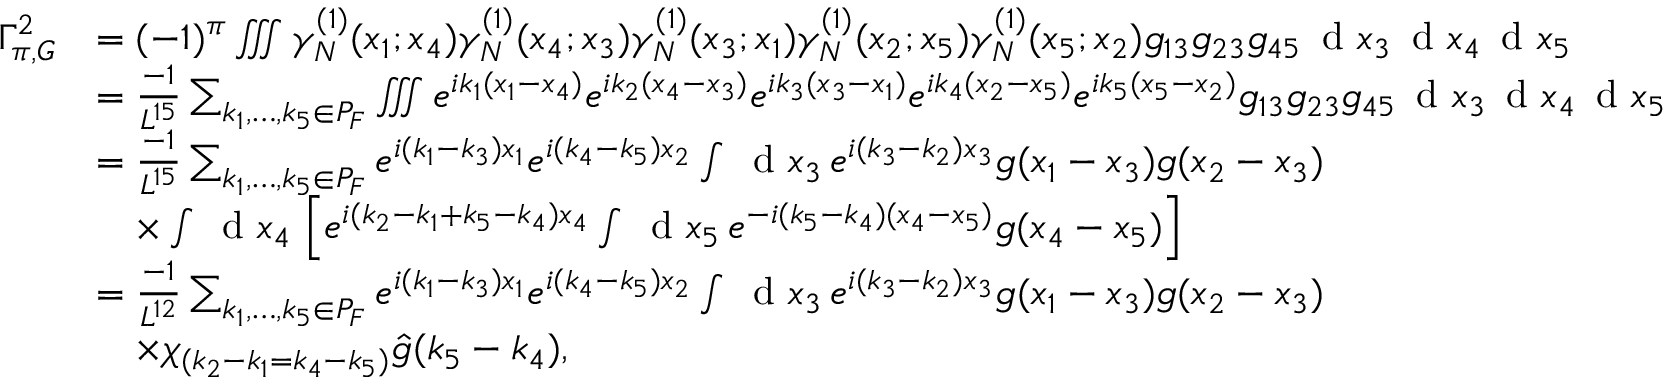Convert formula to latex. <formula><loc_0><loc_0><loc_500><loc_500>\begin{array} { r l } { \Gamma _ { \pi , G } ^ { 2 } } & { = ( - 1 ) ^ { \pi } \iiint \gamma _ { N } ^ { ( 1 ) } ( x _ { 1 } ; x _ { 4 } ) \gamma _ { N } ^ { ( 1 ) } ( x _ { 4 } ; x _ { 3 } ) \gamma _ { N } ^ { ( 1 ) } ( x _ { 3 } ; x _ { 1 } ) \gamma _ { N } ^ { ( 1 ) } ( x _ { 2 } ; x _ { 5 } ) \gamma _ { N } ^ { ( 1 ) } ( x _ { 5 } ; x _ { 2 } ) g _ { 1 3 } g _ { 2 3 } g _ { 4 5 } \, d x _ { 3 } \, d x _ { 4 } \, d x _ { 5 } } \\ & { = \frac { - 1 } { L ^ { 1 5 } } \sum _ { k _ { 1 } , \dots , k _ { 5 } \in P _ { F } } \iiint e ^ { i k _ { 1 } ( x _ { 1 } - x _ { 4 } ) } e ^ { i k _ { 2 } ( x _ { 4 } - x _ { 3 } ) } e ^ { i k _ { 3 } ( x _ { 3 } - x _ { 1 } ) } e ^ { i k _ { 4 } ( x _ { 2 } - x _ { 5 } ) } e ^ { i k _ { 5 } ( x _ { 5 } - x _ { 2 } ) } g _ { 1 3 } g _ { 2 3 } g _ { 4 5 } \, d x _ { 3 } \, d x _ { 4 } \, d x _ { 5 } } \\ & { = \frac { - 1 } { L ^ { 1 5 } } \sum _ { k _ { 1 } , \dots , k _ { 5 } \in P _ { F } } e ^ { i ( k _ { 1 } - k _ { 3 } ) x _ { 1 } } e ^ { i ( k _ { 4 } - k _ { 5 } ) x _ { 2 } } \int \, d x _ { 3 } \, e ^ { i ( k _ { 3 } - k _ { 2 } ) x _ { 3 } } g ( x _ { 1 } - x _ { 3 } ) g ( x _ { 2 } - x _ { 3 } ) } \\ & { \quad \times \int \, d x _ { 4 } \, \left [ e ^ { i ( k _ { 2 } - k _ { 1 } + k _ { 5 } - k _ { 4 } ) x _ { 4 } } \int \, d x _ { 5 } \, e ^ { - i ( k _ { 5 } - k _ { 4 } ) ( x _ { 4 } - x _ { 5 } ) } g ( x _ { 4 } - x _ { 5 } ) \right ] } \\ & { = \frac { - 1 } { L ^ { 1 2 } } \sum _ { k _ { 1 } , \dots , k _ { 5 } \in P _ { F } } e ^ { i ( k _ { 1 } - k _ { 3 } ) x _ { 1 } } e ^ { i ( k _ { 4 } - k _ { 5 } ) x _ { 2 } } \int \, d x _ { 3 } \, e ^ { i ( k _ { 3 } - k _ { 2 } ) x _ { 3 } } g ( x _ { 1 } - x _ { 3 } ) g ( x _ { 2 } - x _ { 3 } ) } \\ & { \quad \times \chi _ { ( k _ { 2 } - k _ { 1 } = k _ { 4 } - k _ { 5 } ) } \hat { g } ( k _ { 5 } - k _ { 4 } ) , } \end{array}</formula> 